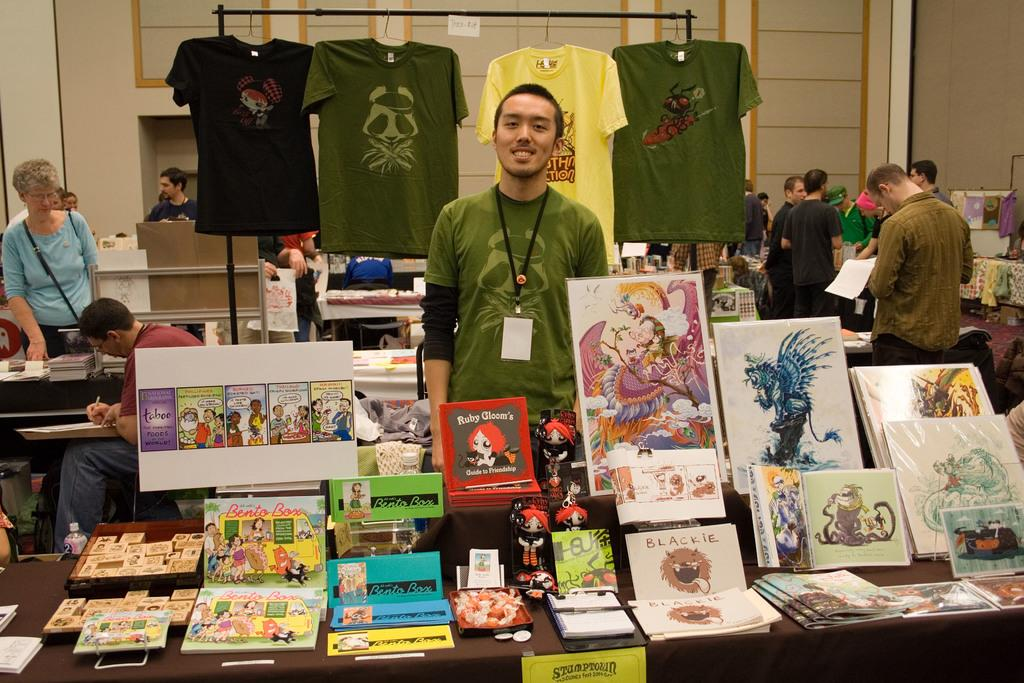<image>
Offer a succinct explanation of the picture presented. A man at his exhibit showcasing artwork and books including Ruby Gloom's Guide to Friendship. 